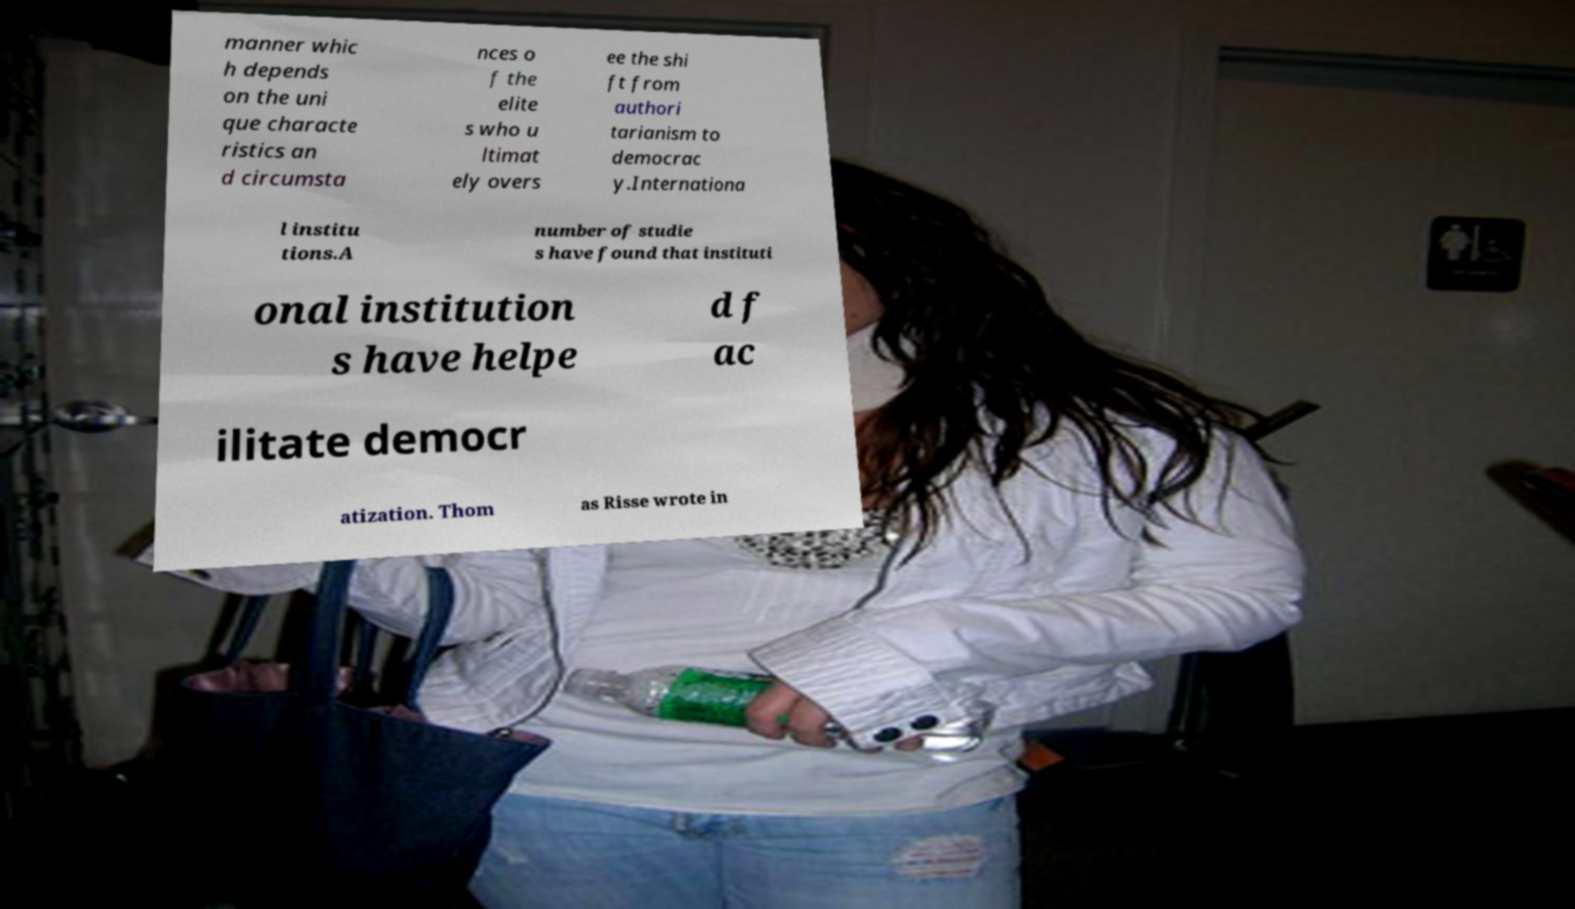What messages or text are displayed in this image? I need them in a readable, typed format. manner whic h depends on the uni que characte ristics an d circumsta nces o f the elite s who u ltimat ely overs ee the shi ft from authori tarianism to democrac y.Internationa l institu tions.A number of studie s have found that instituti onal institution s have helpe d f ac ilitate democr atization. Thom as Risse wrote in 